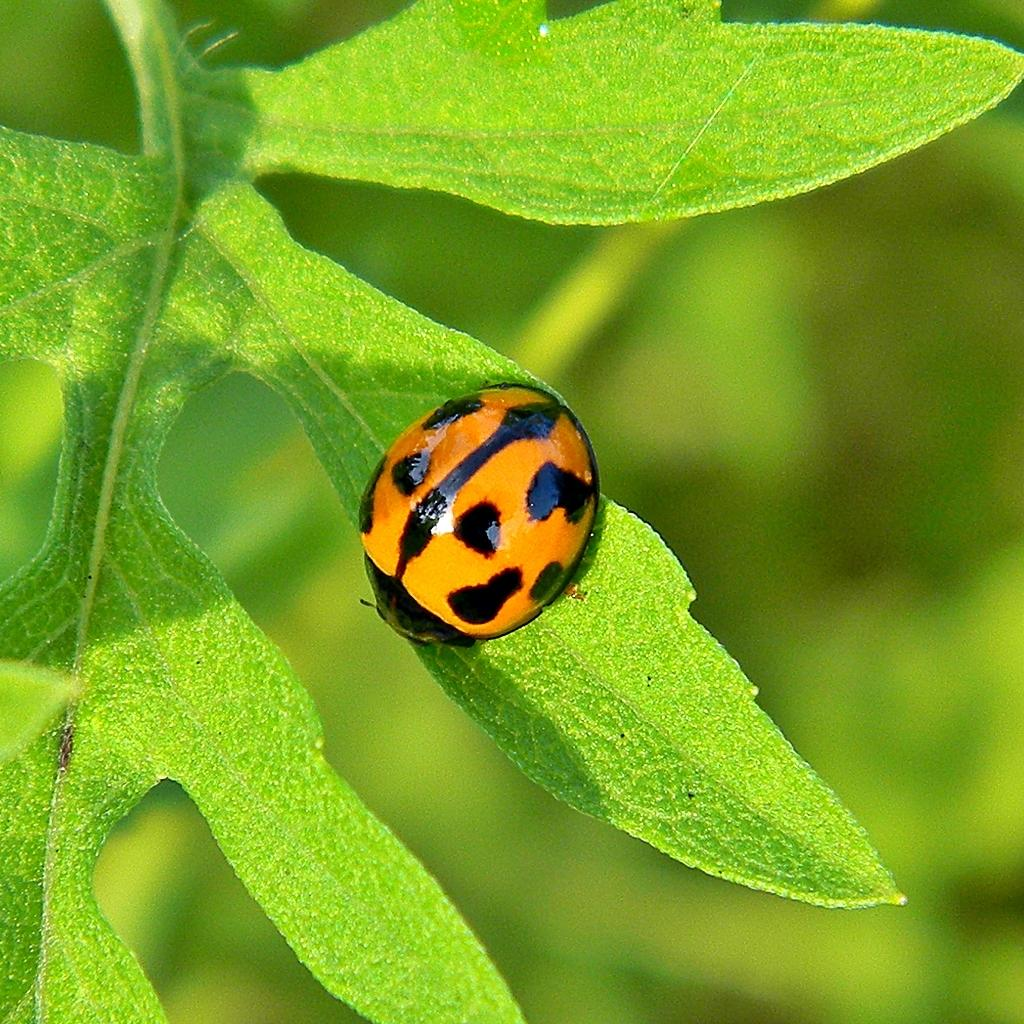What is the main subject of the image? There is an insect in the image. Where is the insect located? The insect is on a leaf. Can you describe the background of the image? The background of the image is blurred. What type of protest is happening in the image? There is no protest present in the image; it features an insect on a leaf with a blurred background. 